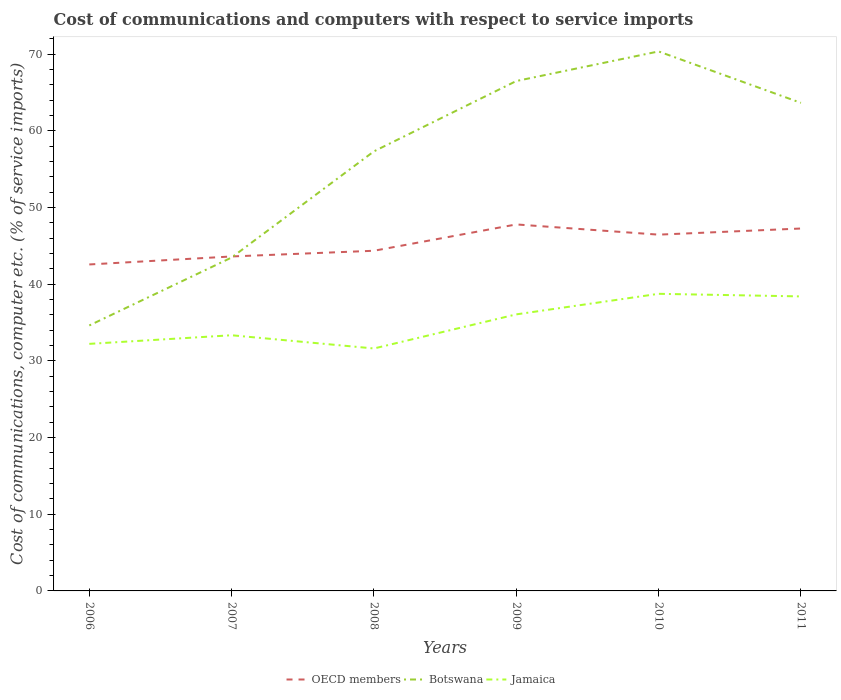Does the line corresponding to OECD members intersect with the line corresponding to Jamaica?
Offer a very short reply. No. Across all years, what is the maximum cost of communications and computers in Botswana?
Provide a succinct answer. 34.63. What is the total cost of communications and computers in Botswana in the graph?
Provide a succinct answer. -20.17. What is the difference between the highest and the second highest cost of communications and computers in OECD members?
Provide a succinct answer. 5.22. What is the difference between the highest and the lowest cost of communications and computers in Jamaica?
Make the answer very short. 3. How many lines are there?
Offer a terse response. 3. Does the graph contain any zero values?
Make the answer very short. No. Does the graph contain grids?
Give a very brief answer. No. How many legend labels are there?
Offer a very short reply. 3. What is the title of the graph?
Ensure brevity in your answer.  Cost of communications and computers with respect to service imports. What is the label or title of the X-axis?
Offer a terse response. Years. What is the label or title of the Y-axis?
Ensure brevity in your answer.  Cost of communications, computer etc. (% of service imports). What is the Cost of communications, computer etc. (% of service imports) in OECD members in 2006?
Give a very brief answer. 42.58. What is the Cost of communications, computer etc. (% of service imports) in Botswana in 2006?
Give a very brief answer. 34.63. What is the Cost of communications, computer etc. (% of service imports) of Jamaica in 2006?
Your answer should be very brief. 32.23. What is the Cost of communications, computer etc. (% of service imports) of OECD members in 2007?
Give a very brief answer. 43.63. What is the Cost of communications, computer etc. (% of service imports) of Botswana in 2007?
Keep it short and to the point. 43.49. What is the Cost of communications, computer etc. (% of service imports) of Jamaica in 2007?
Offer a terse response. 33.35. What is the Cost of communications, computer etc. (% of service imports) in OECD members in 2008?
Provide a short and direct response. 44.37. What is the Cost of communications, computer etc. (% of service imports) of Botswana in 2008?
Keep it short and to the point. 57.34. What is the Cost of communications, computer etc. (% of service imports) in Jamaica in 2008?
Provide a short and direct response. 31.62. What is the Cost of communications, computer etc. (% of service imports) in OECD members in 2009?
Your answer should be very brief. 47.8. What is the Cost of communications, computer etc. (% of service imports) of Botswana in 2009?
Keep it short and to the point. 66.51. What is the Cost of communications, computer etc. (% of service imports) in Jamaica in 2009?
Provide a short and direct response. 36.07. What is the Cost of communications, computer etc. (% of service imports) of OECD members in 2010?
Offer a terse response. 46.47. What is the Cost of communications, computer etc. (% of service imports) in Botswana in 2010?
Offer a very short reply. 70.37. What is the Cost of communications, computer etc. (% of service imports) in Jamaica in 2010?
Your response must be concise. 38.75. What is the Cost of communications, computer etc. (% of service imports) of OECD members in 2011?
Offer a terse response. 47.27. What is the Cost of communications, computer etc. (% of service imports) in Botswana in 2011?
Give a very brief answer. 63.66. What is the Cost of communications, computer etc. (% of service imports) in Jamaica in 2011?
Make the answer very short. 38.41. Across all years, what is the maximum Cost of communications, computer etc. (% of service imports) in OECD members?
Keep it short and to the point. 47.8. Across all years, what is the maximum Cost of communications, computer etc. (% of service imports) of Botswana?
Ensure brevity in your answer.  70.37. Across all years, what is the maximum Cost of communications, computer etc. (% of service imports) in Jamaica?
Your answer should be compact. 38.75. Across all years, what is the minimum Cost of communications, computer etc. (% of service imports) of OECD members?
Provide a succinct answer. 42.58. Across all years, what is the minimum Cost of communications, computer etc. (% of service imports) in Botswana?
Keep it short and to the point. 34.63. Across all years, what is the minimum Cost of communications, computer etc. (% of service imports) in Jamaica?
Make the answer very short. 31.62. What is the total Cost of communications, computer etc. (% of service imports) in OECD members in the graph?
Ensure brevity in your answer.  272.12. What is the total Cost of communications, computer etc. (% of service imports) of Botswana in the graph?
Provide a short and direct response. 335.99. What is the total Cost of communications, computer etc. (% of service imports) of Jamaica in the graph?
Your answer should be compact. 210.44. What is the difference between the Cost of communications, computer etc. (% of service imports) in OECD members in 2006 and that in 2007?
Your response must be concise. -1.04. What is the difference between the Cost of communications, computer etc. (% of service imports) of Botswana in 2006 and that in 2007?
Offer a very short reply. -8.86. What is the difference between the Cost of communications, computer etc. (% of service imports) of Jamaica in 2006 and that in 2007?
Your response must be concise. -1.12. What is the difference between the Cost of communications, computer etc. (% of service imports) of OECD members in 2006 and that in 2008?
Provide a short and direct response. -1.79. What is the difference between the Cost of communications, computer etc. (% of service imports) of Botswana in 2006 and that in 2008?
Offer a terse response. -22.71. What is the difference between the Cost of communications, computer etc. (% of service imports) of Jamaica in 2006 and that in 2008?
Give a very brief answer. 0.6. What is the difference between the Cost of communications, computer etc. (% of service imports) of OECD members in 2006 and that in 2009?
Offer a very short reply. -5.22. What is the difference between the Cost of communications, computer etc. (% of service imports) of Botswana in 2006 and that in 2009?
Offer a very short reply. -31.88. What is the difference between the Cost of communications, computer etc. (% of service imports) of Jamaica in 2006 and that in 2009?
Ensure brevity in your answer.  -3.85. What is the difference between the Cost of communications, computer etc. (% of service imports) in OECD members in 2006 and that in 2010?
Offer a very short reply. -3.89. What is the difference between the Cost of communications, computer etc. (% of service imports) of Botswana in 2006 and that in 2010?
Offer a very short reply. -35.74. What is the difference between the Cost of communications, computer etc. (% of service imports) in Jamaica in 2006 and that in 2010?
Offer a terse response. -6.53. What is the difference between the Cost of communications, computer etc. (% of service imports) in OECD members in 2006 and that in 2011?
Your response must be concise. -4.69. What is the difference between the Cost of communications, computer etc. (% of service imports) in Botswana in 2006 and that in 2011?
Make the answer very short. -29.03. What is the difference between the Cost of communications, computer etc. (% of service imports) of Jamaica in 2006 and that in 2011?
Make the answer very short. -6.19. What is the difference between the Cost of communications, computer etc. (% of service imports) of OECD members in 2007 and that in 2008?
Ensure brevity in your answer.  -0.74. What is the difference between the Cost of communications, computer etc. (% of service imports) in Botswana in 2007 and that in 2008?
Offer a very short reply. -13.85. What is the difference between the Cost of communications, computer etc. (% of service imports) of Jamaica in 2007 and that in 2008?
Make the answer very short. 1.73. What is the difference between the Cost of communications, computer etc. (% of service imports) of OECD members in 2007 and that in 2009?
Give a very brief answer. -4.18. What is the difference between the Cost of communications, computer etc. (% of service imports) of Botswana in 2007 and that in 2009?
Provide a short and direct response. -23.02. What is the difference between the Cost of communications, computer etc. (% of service imports) of Jamaica in 2007 and that in 2009?
Offer a very short reply. -2.72. What is the difference between the Cost of communications, computer etc. (% of service imports) in OECD members in 2007 and that in 2010?
Provide a succinct answer. -2.85. What is the difference between the Cost of communications, computer etc. (% of service imports) of Botswana in 2007 and that in 2010?
Your answer should be very brief. -26.88. What is the difference between the Cost of communications, computer etc. (% of service imports) of Jamaica in 2007 and that in 2010?
Keep it short and to the point. -5.41. What is the difference between the Cost of communications, computer etc. (% of service imports) of OECD members in 2007 and that in 2011?
Make the answer very short. -3.65. What is the difference between the Cost of communications, computer etc. (% of service imports) in Botswana in 2007 and that in 2011?
Your response must be concise. -20.17. What is the difference between the Cost of communications, computer etc. (% of service imports) of Jamaica in 2007 and that in 2011?
Your answer should be compact. -5.07. What is the difference between the Cost of communications, computer etc. (% of service imports) in OECD members in 2008 and that in 2009?
Your response must be concise. -3.43. What is the difference between the Cost of communications, computer etc. (% of service imports) in Botswana in 2008 and that in 2009?
Your answer should be very brief. -9.17. What is the difference between the Cost of communications, computer etc. (% of service imports) of Jamaica in 2008 and that in 2009?
Provide a succinct answer. -4.45. What is the difference between the Cost of communications, computer etc. (% of service imports) in OECD members in 2008 and that in 2010?
Give a very brief answer. -2.1. What is the difference between the Cost of communications, computer etc. (% of service imports) in Botswana in 2008 and that in 2010?
Your response must be concise. -13.03. What is the difference between the Cost of communications, computer etc. (% of service imports) of Jamaica in 2008 and that in 2010?
Provide a succinct answer. -7.13. What is the difference between the Cost of communications, computer etc. (% of service imports) in OECD members in 2008 and that in 2011?
Offer a very short reply. -2.9. What is the difference between the Cost of communications, computer etc. (% of service imports) in Botswana in 2008 and that in 2011?
Provide a short and direct response. -6.32. What is the difference between the Cost of communications, computer etc. (% of service imports) in Jamaica in 2008 and that in 2011?
Offer a very short reply. -6.79. What is the difference between the Cost of communications, computer etc. (% of service imports) of OECD members in 2009 and that in 2010?
Ensure brevity in your answer.  1.33. What is the difference between the Cost of communications, computer etc. (% of service imports) in Botswana in 2009 and that in 2010?
Provide a succinct answer. -3.86. What is the difference between the Cost of communications, computer etc. (% of service imports) of Jamaica in 2009 and that in 2010?
Provide a succinct answer. -2.68. What is the difference between the Cost of communications, computer etc. (% of service imports) of OECD members in 2009 and that in 2011?
Your response must be concise. 0.53. What is the difference between the Cost of communications, computer etc. (% of service imports) in Botswana in 2009 and that in 2011?
Offer a very short reply. 2.85. What is the difference between the Cost of communications, computer etc. (% of service imports) in Jamaica in 2009 and that in 2011?
Provide a short and direct response. -2.34. What is the difference between the Cost of communications, computer etc. (% of service imports) of OECD members in 2010 and that in 2011?
Your answer should be compact. -0.8. What is the difference between the Cost of communications, computer etc. (% of service imports) in Botswana in 2010 and that in 2011?
Give a very brief answer. 6.71. What is the difference between the Cost of communications, computer etc. (% of service imports) in Jamaica in 2010 and that in 2011?
Keep it short and to the point. 0.34. What is the difference between the Cost of communications, computer etc. (% of service imports) of OECD members in 2006 and the Cost of communications, computer etc. (% of service imports) of Botswana in 2007?
Provide a succinct answer. -0.91. What is the difference between the Cost of communications, computer etc. (% of service imports) in OECD members in 2006 and the Cost of communications, computer etc. (% of service imports) in Jamaica in 2007?
Your answer should be very brief. 9.23. What is the difference between the Cost of communications, computer etc. (% of service imports) in Botswana in 2006 and the Cost of communications, computer etc. (% of service imports) in Jamaica in 2007?
Ensure brevity in your answer.  1.28. What is the difference between the Cost of communications, computer etc. (% of service imports) of OECD members in 2006 and the Cost of communications, computer etc. (% of service imports) of Botswana in 2008?
Provide a succinct answer. -14.75. What is the difference between the Cost of communications, computer etc. (% of service imports) of OECD members in 2006 and the Cost of communications, computer etc. (% of service imports) of Jamaica in 2008?
Offer a terse response. 10.96. What is the difference between the Cost of communications, computer etc. (% of service imports) of Botswana in 2006 and the Cost of communications, computer etc. (% of service imports) of Jamaica in 2008?
Your response must be concise. 3. What is the difference between the Cost of communications, computer etc. (% of service imports) in OECD members in 2006 and the Cost of communications, computer etc. (% of service imports) in Botswana in 2009?
Your answer should be compact. -23.93. What is the difference between the Cost of communications, computer etc. (% of service imports) of OECD members in 2006 and the Cost of communications, computer etc. (% of service imports) of Jamaica in 2009?
Your answer should be compact. 6.51. What is the difference between the Cost of communications, computer etc. (% of service imports) of Botswana in 2006 and the Cost of communications, computer etc. (% of service imports) of Jamaica in 2009?
Your response must be concise. -1.45. What is the difference between the Cost of communications, computer etc. (% of service imports) of OECD members in 2006 and the Cost of communications, computer etc. (% of service imports) of Botswana in 2010?
Offer a very short reply. -27.79. What is the difference between the Cost of communications, computer etc. (% of service imports) in OECD members in 2006 and the Cost of communications, computer etc. (% of service imports) in Jamaica in 2010?
Provide a succinct answer. 3.83. What is the difference between the Cost of communications, computer etc. (% of service imports) of Botswana in 2006 and the Cost of communications, computer etc. (% of service imports) of Jamaica in 2010?
Offer a terse response. -4.13. What is the difference between the Cost of communications, computer etc. (% of service imports) of OECD members in 2006 and the Cost of communications, computer etc. (% of service imports) of Botswana in 2011?
Offer a very short reply. -21.08. What is the difference between the Cost of communications, computer etc. (% of service imports) of OECD members in 2006 and the Cost of communications, computer etc. (% of service imports) of Jamaica in 2011?
Your answer should be compact. 4.17. What is the difference between the Cost of communications, computer etc. (% of service imports) of Botswana in 2006 and the Cost of communications, computer etc. (% of service imports) of Jamaica in 2011?
Ensure brevity in your answer.  -3.79. What is the difference between the Cost of communications, computer etc. (% of service imports) in OECD members in 2007 and the Cost of communications, computer etc. (% of service imports) in Botswana in 2008?
Keep it short and to the point. -13.71. What is the difference between the Cost of communications, computer etc. (% of service imports) in OECD members in 2007 and the Cost of communications, computer etc. (% of service imports) in Jamaica in 2008?
Offer a terse response. 12. What is the difference between the Cost of communications, computer etc. (% of service imports) of Botswana in 2007 and the Cost of communications, computer etc. (% of service imports) of Jamaica in 2008?
Make the answer very short. 11.86. What is the difference between the Cost of communications, computer etc. (% of service imports) of OECD members in 2007 and the Cost of communications, computer etc. (% of service imports) of Botswana in 2009?
Provide a succinct answer. -22.88. What is the difference between the Cost of communications, computer etc. (% of service imports) of OECD members in 2007 and the Cost of communications, computer etc. (% of service imports) of Jamaica in 2009?
Offer a very short reply. 7.55. What is the difference between the Cost of communications, computer etc. (% of service imports) in Botswana in 2007 and the Cost of communications, computer etc. (% of service imports) in Jamaica in 2009?
Give a very brief answer. 7.42. What is the difference between the Cost of communications, computer etc. (% of service imports) of OECD members in 2007 and the Cost of communications, computer etc. (% of service imports) of Botswana in 2010?
Make the answer very short. -26.74. What is the difference between the Cost of communications, computer etc. (% of service imports) in OECD members in 2007 and the Cost of communications, computer etc. (% of service imports) in Jamaica in 2010?
Your answer should be very brief. 4.87. What is the difference between the Cost of communications, computer etc. (% of service imports) of Botswana in 2007 and the Cost of communications, computer etc. (% of service imports) of Jamaica in 2010?
Keep it short and to the point. 4.73. What is the difference between the Cost of communications, computer etc. (% of service imports) in OECD members in 2007 and the Cost of communications, computer etc. (% of service imports) in Botswana in 2011?
Your answer should be very brief. -20.04. What is the difference between the Cost of communications, computer etc. (% of service imports) in OECD members in 2007 and the Cost of communications, computer etc. (% of service imports) in Jamaica in 2011?
Make the answer very short. 5.21. What is the difference between the Cost of communications, computer etc. (% of service imports) in Botswana in 2007 and the Cost of communications, computer etc. (% of service imports) in Jamaica in 2011?
Make the answer very short. 5.07. What is the difference between the Cost of communications, computer etc. (% of service imports) in OECD members in 2008 and the Cost of communications, computer etc. (% of service imports) in Botswana in 2009?
Provide a succinct answer. -22.14. What is the difference between the Cost of communications, computer etc. (% of service imports) of OECD members in 2008 and the Cost of communications, computer etc. (% of service imports) of Jamaica in 2009?
Offer a terse response. 8.3. What is the difference between the Cost of communications, computer etc. (% of service imports) in Botswana in 2008 and the Cost of communications, computer etc. (% of service imports) in Jamaica in 2009?
Your answer should be very brief. 21.26. What is the difference between the Cost of communications, computer etc. (% of service imports) in OECD members in 2008 and the Cost of communications, computer etc. (% of service imports) in Botswana in 2010?
Keep it short and to the point. -26. What is the difference between the Cost of communications, computer etc. (% of service imports) of OECD members in 2008 and the Cost of communications, computer etc. (% of service imports) of Jamaica in 2010?
Your response must be concise. 5.62. What is the difference between the Cost of communications, computer etc. (% of service imports) in Botswana in 2008 and the Cost of communications, computer etc. (% of service imports) in Jamaica in 2010?
Your answer should be very brief. 18.58. What is the difference between the Cost of communications, computer etc. (% of service imports) of OECD members in 2008 and the Cost of communications, computer etc. (% of service imports) of Botswana in 2011?
Offer a terse response. -19.29. What is the difference between the Cost of communications, computer etc. (% of service imports) in OECD members in 2008 and the Cost of communications, computer etc. (% of service imports) in Jamaica in 2011?
Keep it short and to the point. 5.96. What is the difference between the Cost of communications, computer etc. (% of service imports) in Botswana in 2008 and the Cost of communications, computer etc. (% of service imports) in Jamaica in 2011?
Make the answer very short. 18.92. What is the difference between the Cost of communications, computer etc. (% of service imports) in OECD members in 2009 and the Cost of communications, computer etc. (% of service imports) in Botswana in 2010?
Provide a short and direct response. -22.57. What is the difference between the Cost of communications, computer etc. (% of service imports) of OECD members in 2009 and the Cost of communications, computer etc. (% of service imports) of Jamaica in 2010?
Keep it short and to the point. 9.05. What is the difference between the Cost of communications, computer etc. (% of service imports) of Botswana in 2009 and the Cost of communications, computer etc. (% of service imports) of Jamaica in 2010?
Make the answer very short. 27.75. What is the difference between the Cost of communications, computer etc. (% of service imports) in OECD members in 2009 and the Cost of communications, computer etc. (% of service imports) in Botswana in 2011?
Your answer should be very brief. -15.86. What is the difference between the Cost of communications, computer etc. (% of service imports) of OECD members in 2009 and the Cost of communications, computer etc. (% of service imports) of Jamaica in 2011?
Your response must be concise. 9.39. What is the difference between the Cost of communications, computer etc. (% of service imports) in Botswana in 2009 and the Cost of communications, computer etc. (% of service imports) in Jamaica in 2011?
Ensure brevity in your answer.  28.09. What is the difference between the Cost of communications, computer etc. (% of service imports) in OECD members in 2010 and the Cost of communications, computer etc. (% of service imports) in Botswana in 2011?
Your answer should be compact. -17.19. What is the difference between the Cost of communications, computer etc. (% of service imports) in OECD members in 2010 and the Cost of communications, computer etc. (% of service imports) in Jamaica in 2011?
Give a very brief answer. 8.06. What is the difference between the Cost of communications, computer etc. (% of service imports) of Botswana in 2010 and the Cost of communications, computer etc. (% of service imports) of Jamaica in 2011?
Your answer should be very brief. 31.95. What is the average Cost of communications, computer etc. (% of service imports) of OECD members per year?
Ensure brevity in your answer.  45.35. What is the average Cost of communications, computer etc. (% of service imports) of Botswana per year?
Offer a very short reply. 56. What is the average Cost of communications, computer etc. (% of service imports) in Jamaica per year?
Your answer should be very brief. 35.07. In the year 2006, what is the difference between the Cost of communications, computer etc. (% of service imports) in OECD members and Cost of communications, computer etc. (% of service imports) in Botswana?
Offer a terse response. 7.96. In the year 2006, what is the difference between the Cost of communications, computer etc. (% of service imports) in OECD members and Cost of communications, computer etc. (% of service imports) in Jamaica?
Give a very brief answer. 10.36. In the year 2006, what is the difference between the Cost of communications, computer etc. (% of service imports) of Botswana and Cost of communications, computer etc. (% of service imports) of Jamaica?
Provide a succinct answer. 2.4. In the year 2007, what is the difference between the Cost of communications, computer etc. (% of service imports) in OECD members and Cost of communications, computer etc. (% of service imports) in Botswana?
Ensure brevity in your answer.  0.14. In the year 2007, what is the difference between the Cost of communications, computer etc. (% of service imports) of OECD members and Cost of communications, computer etc. (% of service imports) of Jamaica?
Your answer should be very brief. 10.28. In the year 2007, what is the difference between the Cost of communications, computer etc. (% of service imports) of Botswana and Cost of communications, computer etc. (% of service imports) of Jamaica?
Offer a very short reply. 10.14. In the year 2008, what is the difference between the Cost of communications, computer etc. (% of service imports) of OECD members and Cost of communications, computer etc. (% of service imports) of Botswana?
Offer a terse response. -12.97. In the year 2008, what is the difference between the Cost of communications, computer etc. (% of service imports) of OECD members and Cost of communications, computer etc. (% of service imports) of Jamaica?
Provide a succinct answer. 12.75. In the year 2008, what is the difference between the Cost of communications, computer etc. (% of service imports) in Botswana and Cost of communications, computer etc. (% of service imports) in Jamaica?
Your answer should be very brief. 25.71. In the year 2009, what is the difference between the Cost of communications, computer etc. (% of service imports) of OECD members and Cost of communications, computer etc. (% of service imports) of Botswana?
Give a very brief answer. -18.7. In the year 2009, what is the difference between the Cost of communications, computer etc. (% of service imports) in OECD members and Cost of communications, computer etc. (% of service imports) in Jamaica?
Offer a very short reply. 11.73. In the year 2009, what is the difference between the Cost of communications, computer etc. (% of service imports) in Botswana and Cost of communications, computer etc. (% of service imports) in Jamaica?
Give a very brief answer. 30.44. In the year 2010, what is the difference between the Cost of communications, computer etc. (% of service imports) of OECD members and Cost of communications, computer etc. (% of service imports) of Botswana?
Keep it short and to the point. -23.9. In the year 2010, what is the difference between the Cost of communications, computer etc. (% of service imports) of OECD members and Cost of communications, computer etc. (% of service imports) of Jamaica?
Keep it short and to the point. 7.72. In the year 2010, what is the difference between the Cost of communications, computer etc. (% of service imports) of Botswana and Cost of communications, computer etc. (% of service imports) of Jamaica?
Ensure brevity in your answer.  31.62. In the year 2011, what is the difference between the Cost of communications, computer etc. (% of service imports) in OECD members and Cost of communications, computer etc. (% of service imports) in Botswana?
Offer a very short reply. -16.39. In the year 2011, what is the difference between the Cost of communications, computer etc. (% of service imports) in OECD members and Cost of communications, computer etc. (% of service imports) in Jamaica?
Make the answer very short. 8.86. In the year 2011, what is the difference between the Cost of communications, computer etc. (% of service imports) of Botswana and Cost of communications, computer etc. (% of service imports) of Jamaica?
Offer a terse response. 25.25. What is the ratio of the Cost of communications, computer etc. (% of service imports) in OECD members in 2006 to that in 2007?
Offer a terse response. 0.98. What is the ratio of the Cost of communications, computer etc. (% of service imports) in Botswana in 2006 to that in 2007?
Ensure brevity in your answer.  0.8. What is the ratio of the Cost of communications, computer etc. (% of service imports) of Jamaica in 2006 to that in 2007?
Keep it short and to the point. 0.97. What is the ratio of the Cost of communications, computer etc. (% of service imports) of OECD members in 2006 to that in 2008?
Your answer should be compact. 0.96. What is the ratio of the Cost of communications, computer etc. (% of service imports) in Botswana in 2006 to that in 2008?
Your response must be concise. 0.6. What is the ratio of the Cost of communications, computer etc. (% of service imports) in OECD members in 2006 to that in 2009?
Your answer should be compact. 0.89. What is the ratio of the Cost of communications, computer etc. (% of service imports) of Botswana in 2006 to that in 2009?
Make the answer very short. 0.52. What is the ratio of the Cost of communications, computer etc. (% of service imports) of Jamaica in 2006 to that in 2009?
Offer a very short reply. 0.89. What is the ratio of the Cost of communications, computer etc. (% of service imports) in OECD members in 2006 to that in 2010?
Ensure brevity in your answer.  0.92. What is the ratio of the Cost of communications, computer etc. (% of service imports) in Botswana in 2006 to that in 2010?
Ensure brevity in your answer.  0.49. What is the ratio of the Cost of communications, computer etc. (% of service imports) of Jamaica in 2006 to that in 2010?
Your answer should be very brief. 0.83. What is the ratio of the Cost of communications, computer etc. (% of service imports) of OECD members in 2006 to that in 2011?
Provide a short and direct response. 0.9. What is the ratio of the Cost of communications, computer etc. (% of service imports) of Botswana in 2006 to that in 2011?
Make the answer very short. 0.54. What is the ratio of the Cost of communications, computer etc. (% of service imports) in Jamaica in 2006 to that in 2011?
Provide a short and direct response. 0.84. What is the ratio of the Cost of communications, computer etc. (% of service imports) of OECD members in 2007 to that in 2008?
Provide a succinct answer. 0.98. What is the ratio of the Cost of communications, computer etc. (% of service imports) of Botswana in 2007 to that in 2008?
Give a very brief answer. 0.76. What is the ratio of the Cost of communications, computer etc. (% of service imports) in Jamaica in 2007 to that in 2008?
Keep it short and to the point. 1.05. What is the ratio of the Cost of communications, computer etc. (% of service imports) in OECD members in 2007 to that in 2009?
Offer a terse response. 0.91. What is the ratio of the Cost of communications, computer etc. (% of service imports) of Botswana in 2007 to that in 2009?
Provide a short and direct response. 0.65. What is the ratio of the Cost of communications, computer etc. (% of service imports) of Jamaica in 2007 to that in 2009?
Offer a very short reply. 0.92. What is the ratio of the Cost of communications, computer etc. (% of service imports) of OECD members in 2007 to that in 2010?
Ensure brevity in your answer.  0.94. What is the ratio of the Cost of communications, computer etc. (% of service imports) in Botswana in 2007 to that in 2010?
Keep it short and to the point. 0.62. What is the ratio of the Cost of communications, computer etc. (% of service imports) of Jamaica in 2007 to that in 2010?
Ensure brevity in your answer.  0.86. What is the ratio of the Cost of communications, computer etc. (% of service imports) in OECD members in 2007 to that in 2011?
Offer a terse response. 0.92. What is the ratio of the Cost of communications, computer etc. (% of service imports) in Botswana in 2007 to that in 2011?
Your response must be concise. 0.68. What is the ratio of the Cost of communications, computer etc. (% of service imports) in Jamaica in 2007 to that in 2011?
Make the answer very short. 0.87. What is the ratio of the Cost of communications, computer etc. (% of service imports) of OECD members in 2008 to that in 2009?
Provide a short and direct response. 0.93. What is the ratio of the Cost of communications, computer etc. (% of service imports) in Botswana in 2008 to that in 2009?
Ensure brevity in your answer.  0.86. What is the ratio of the Cost of communications, computer etc. (% of service imports) of Jamaica in 2008 to that in 2009?
Your answer should be very brief. 0.88. What is the ratio of the Cost of communications, computer etc. (% of service imports) of OECD members in 2008 to that in 2010?
Your answer should be very brief. 0.95. What is the ratio of the Cost of communications, computer etc. (% of service imports) in Botswana in 2008 to that in 2010?
Your answer should be very brief. 0.81. What is the ratio of the Cost of communications, computer etc. (% of service imports) in Jamaica in 2008 to that in 2010?
Provide a succinct answer. 0.82. What is the ratio of the Cost of communications, computer etc. (% of service imports) of OECD members in 2008 to that in 2011?
Ensure brevity in your answer.  0.94. What is the ratio of the Cost of communications, computer etc. (% of service imports) of Botswana in 2008 to that in 2011?
Your answer should be compact. 0.9. What is the ratio of the Cost of communications, computer etc. (% of service imports) in Jamaica in 2008 to that in 2011?
Your answer should be very brief. 0.82. What is the ratio of the Cost of communications, computer etc. (% of service imports) in OECD members in 2009 to that in 2010?
Your response must be concise. 1.03. What is the ratio of the Cost of communications, computer etc. (% of service imports) in Botswana in 2009 to that in 2010?
Your answer should be compact. 0.95. What is the ratio of the Cost of communications, computer etc. (% of service imports) of Jamaica in 2009 to that in 2010?
Provide a succinct answer. 0.93. What is the ratio of the Cost of communications, computer etc. (% of service imports) of OECD members in 2009 to that in 2011?
Your answer should be compact. 1.01. What is the ratio of the Cost of communications, computer etc. (% of service imports) in Botswana in 2009 to that in 2011?
Provide a short and direct response. 1.04. What is the ratio of the Cost of communications, computer etc. (% of service imports) of Jamaica in 2009 to that in 2011?
Your answer should be compact. 0.94. What is the ratio of the Cost of communications, computer etc. (% of service imports) in OECD members in 2010 to that in 2011?
Your answer should be compact. 0.98. What is the ratio of the Cost of communications, computer etc. (% of service imports) in Botswana in 2010 to that in 2011?
Provide a succinct answer. 1.11. What is the ratio of the Cost of communications, computer etc. (% of service imports) in Jamaica in 2010 to that in 2011?
Offer a terse response. 1.01. What is the difference between the highest and the second highest Cost of communications, computer etc. (% of service imports) of OECD members?
Make the answer very short. 0.53. What is the difference between the highest and the second highest Cost of communications, computer etc. (% of service imports) of Botswana?
Your answer should be very brief. 3.86. What is the difference between the highest and the second highest Cost of communications, computer etc. (% of service imports) in Jamaica?
Your answer should be compact. 0.34. What is the difference between the highest and the lowest Cost of communications, computer etc. (% of service imports) in OECD members?
Keep it short and to the point. 5.22. What is the difference between the highest and the lowest Cost of communications, computer etc. (% of service imports) in Botswana?
Provide a succinct answer. 35.74. What is the difference between the highest and the lowest Cost of communications, computer etc. (% of service imports) in Jamaica?
Your answer should be very brief. 7.13. 